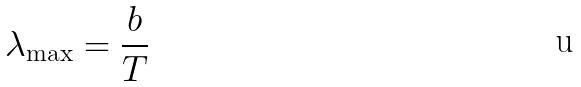<formula> <loc_0><loc_0><loc_500><loc_500>\lambda _ { \max } = \frac { b } { T }</formula> 